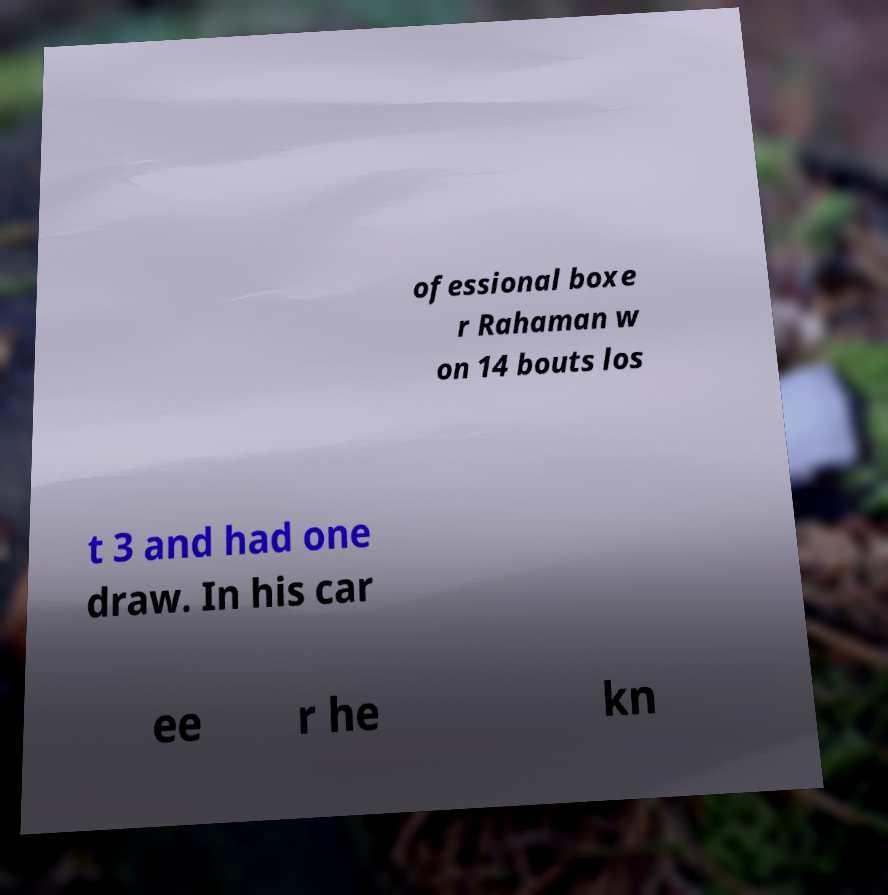Please identify and transcribe the text found in this image. ofessional boxe r Rahaman w on 14 bouts los t 3 and had one draw. In his car ee r he kn 